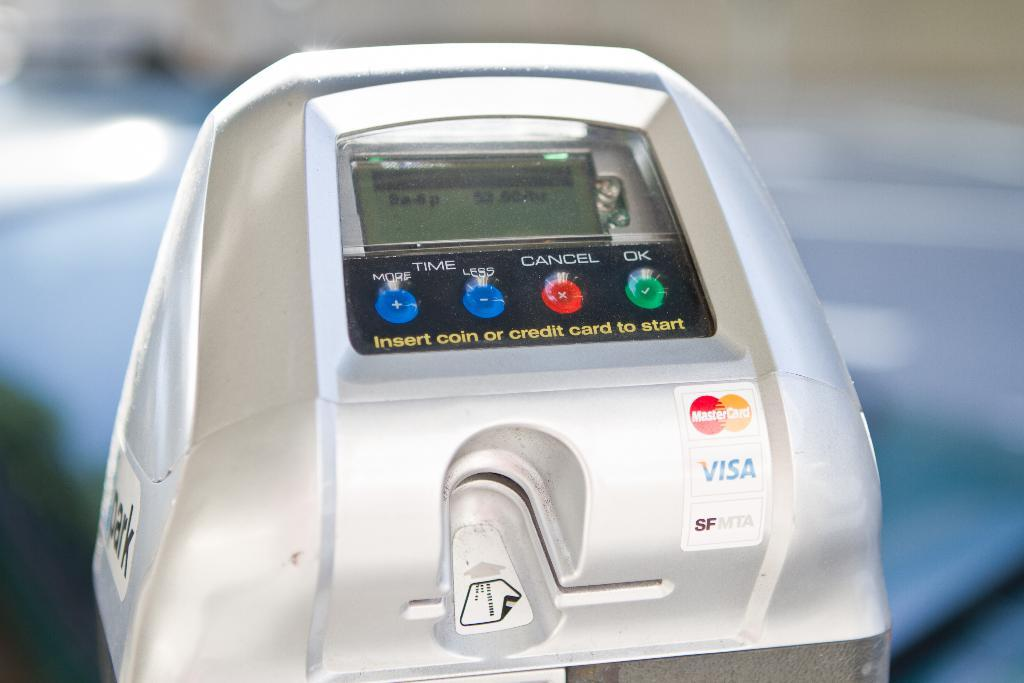<image>
Present a compact description of the photo's key features. New age, silver parking meter that accepts Visa and MasterCard. 